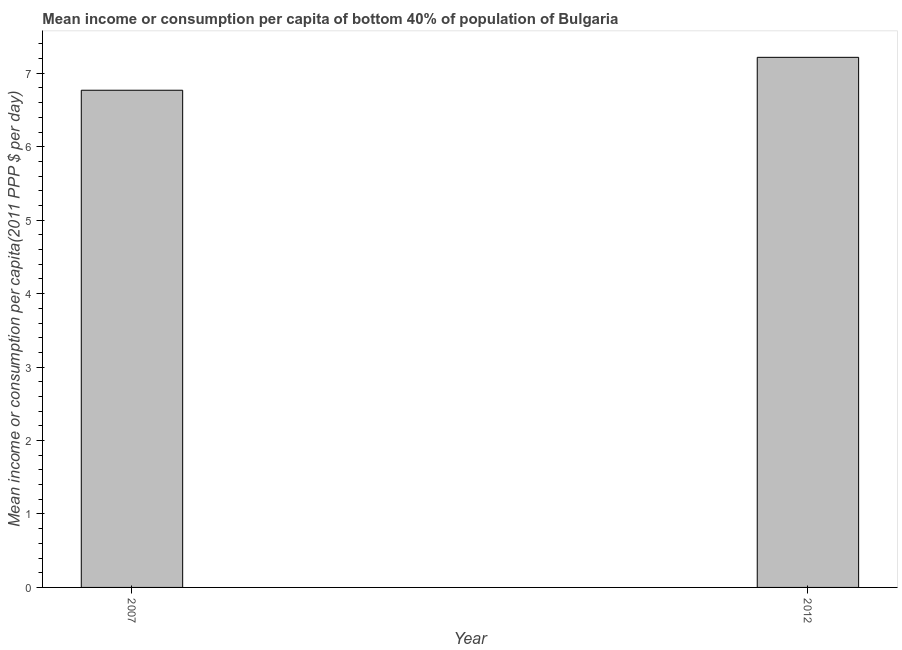Does the graph contain grids?
Provide a succinct answer. No. What is the title of the graph?
Ensure brevity in your answer.  Mean income or consumption per capita of bottom 40% of population of Bulgaria. What is the label or title of the X-axis?
Your answer should be compact. Year. What is the label or title of the Y-axis?
Your answer should be compact. Mean income or consumption per capita(2011 PPP $ per day). What is the mean income or consumption in 2012?
Your response must be concise. 7.22. Across all years, what is the maximum mean income or consumption?
Make the answer very short. 7.22. Across all years, what is the minimum mean income or consumption?
Provide a short and direct response. 6.77. What is the sum of the mean income or consumption?
Your response must be concise. 13.99. What is the difference between the mean income or consumption in 2007 and 2012?
Your answer should be very brief. -0.45. What is the average mean income or consumption per year?
Provide a short and direct response. 6.99. What is the median mean income or consumption?
Your answer should be compact. 6.99. In how many years, is the mean income or consumption greater than 4.2 $?
Ensure brevity in your answer.  2. What is the ratio of the mean income or consumption in 2007 to that in 2012?
Provide a succinct answer. 0.94. Is the mean income or consumption in 2007 less than that in 2012?
Make the answer very short. Yes. How many years are there in the graph?
Make the answer very short. 2. What is the Mean income or consumption per capita(2011 PPP $ per day) of 2007?
Your answer should be very brief. 6.77. What is the Mean income or consumption per capita(2011 PPP $ per day) in 2012?
Your answer should be compact. 7.22. What is the difference between the Mean income or consumption per capita(2011 PPP $ per day) in 2007 and 2012?
Keep it short and to the point. -0.45. What is the ratio of the Mean income or consumption per capita(2011 PPP $ per day) in 2007 to that in 2012?
Provide a succinct answer. 0.94. 